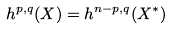Convert formula to latex. <formula><loc_0><loc_0><loc_500><loc_500>h ^ { p , q } ( X ) = h ^ { n - p , q } ( X ^ { * } )</formula> 